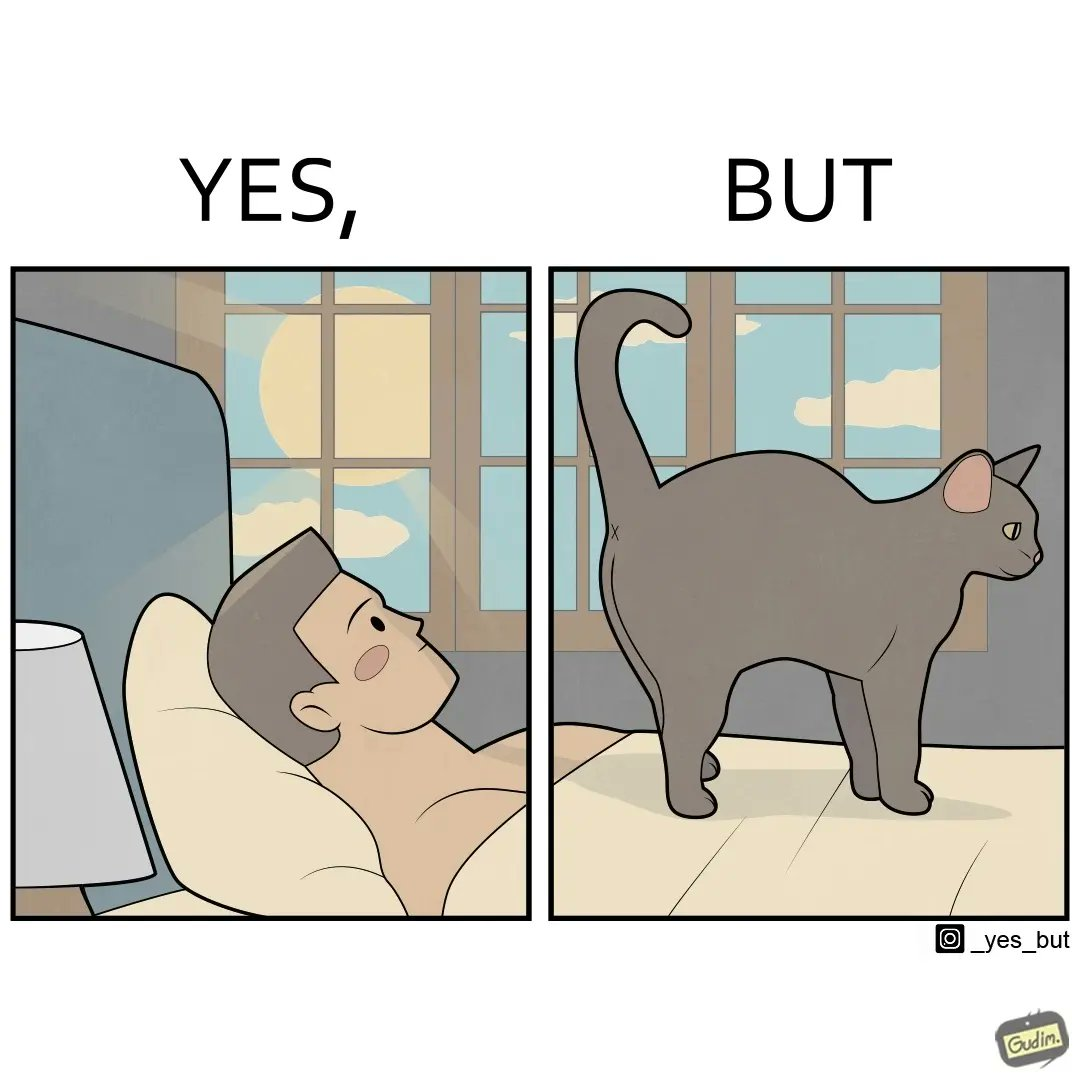Is there satirical content in this image? Yes, this image is satirical. 